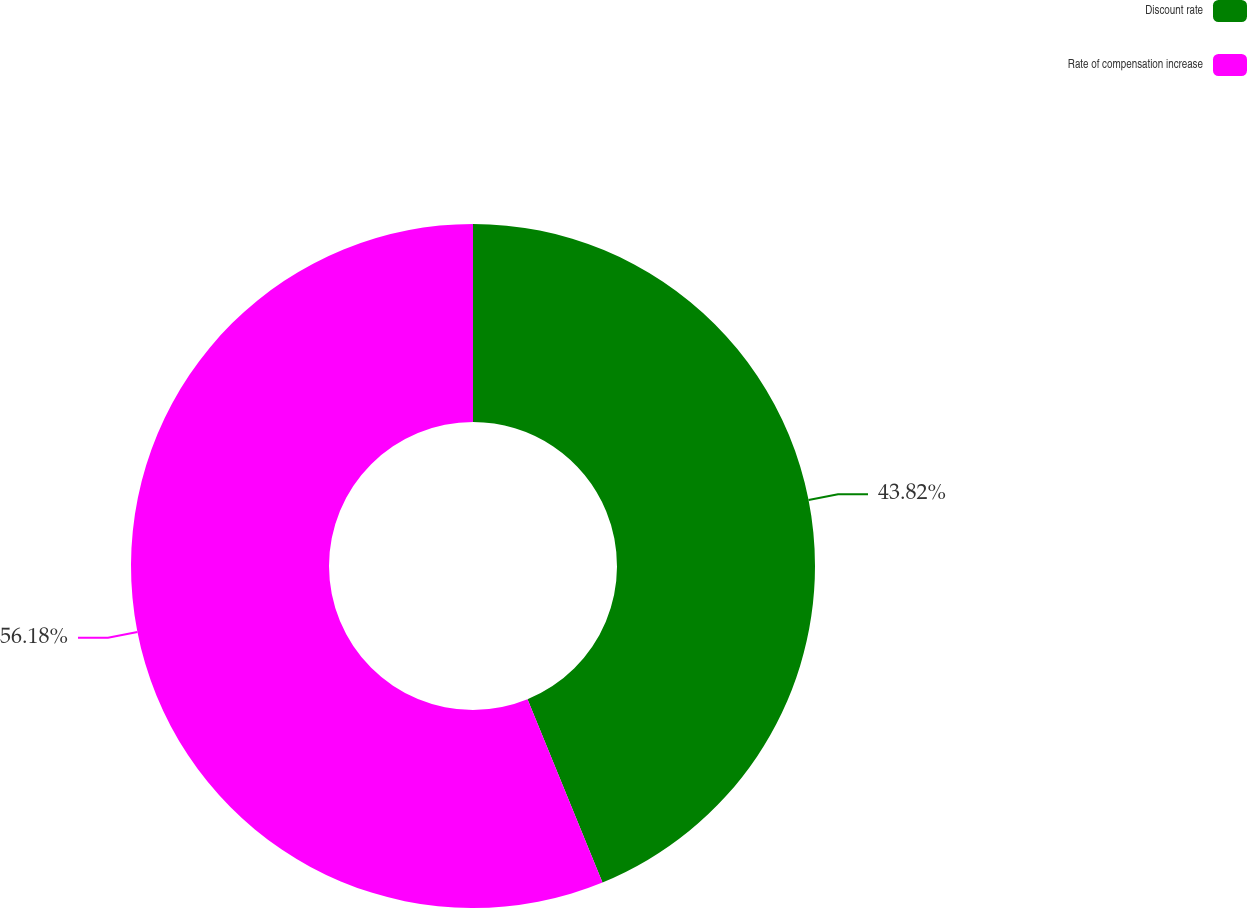Convert chart. <chart><loc_0><loc_0><loc_500><loc_500><pie_chart><fcel>Discount rate<fcel>Rate of compensation increase<nl><fcel>43.82%<fcel>56.18%<nl></chart> 